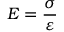Convert formula to latex. <formula><loc_0><loc_0><loc_500><loc_500>E = { \frac { \sigma } { \varepsilon } }</formula> 